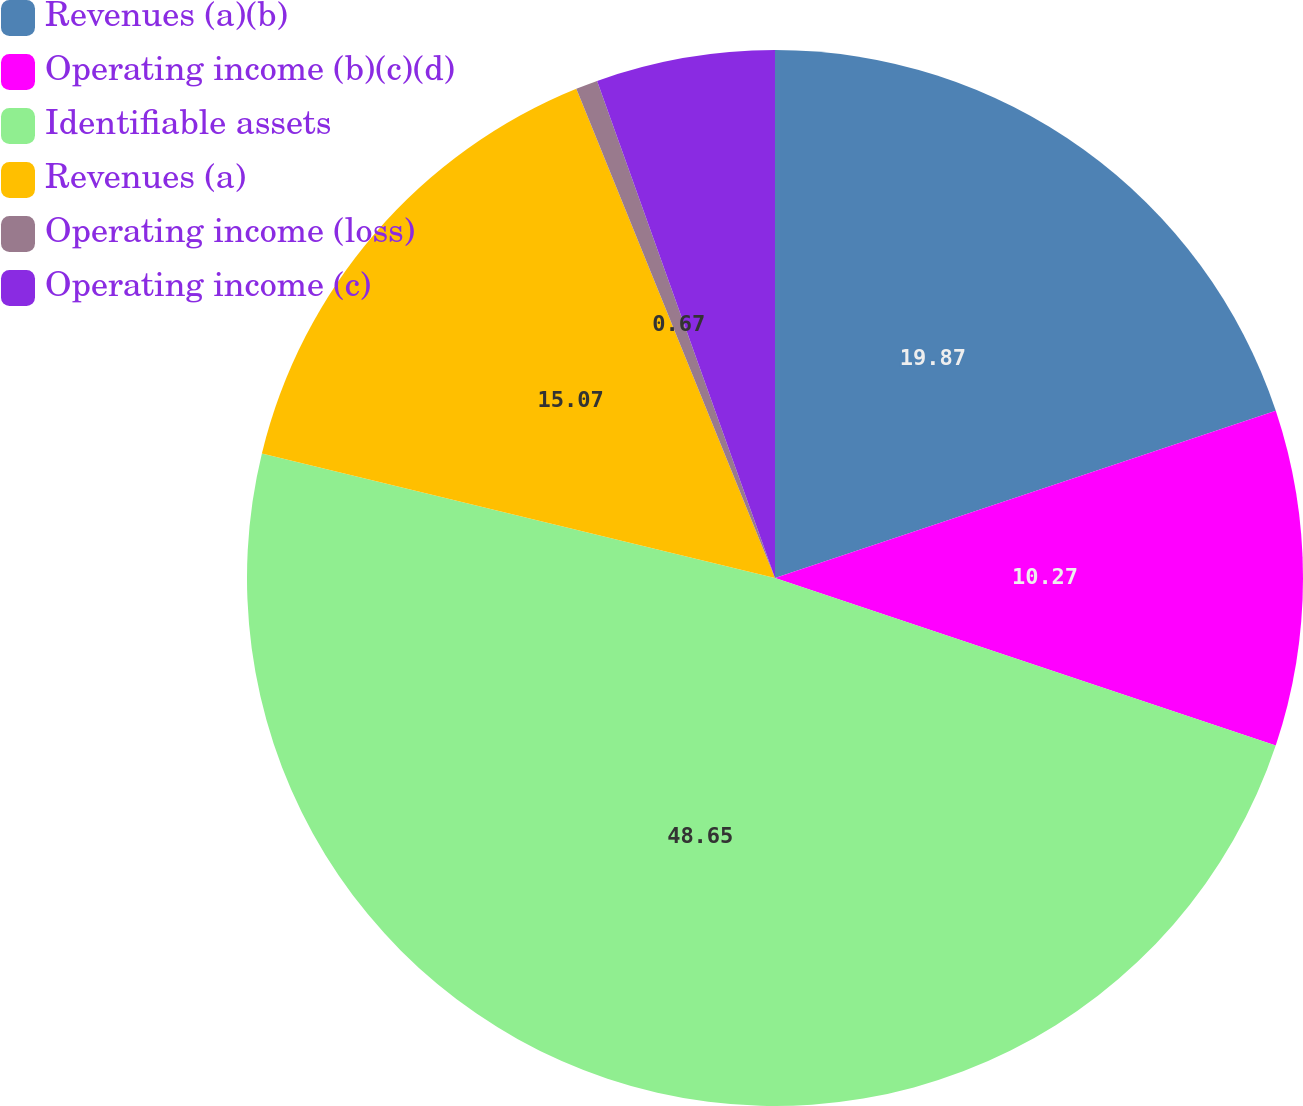Convert chart to OTSL. <chart><loc_0><loc_0><loc_500><loc_500><pie_chart><fcel>Revenues (a)(b)<fcel>Operating income (b)(c)(d)<fcel>Identifiable assets<fcel>Revenues (a)<fcel>Operating income (loss)<fcel>Operating income (c)<nl><fcel>19.87%<fcel>10.27%<fcel>48.65%<fcel>15.07%<fcel>0.67%<fcel>5.47%<nl></chart> 